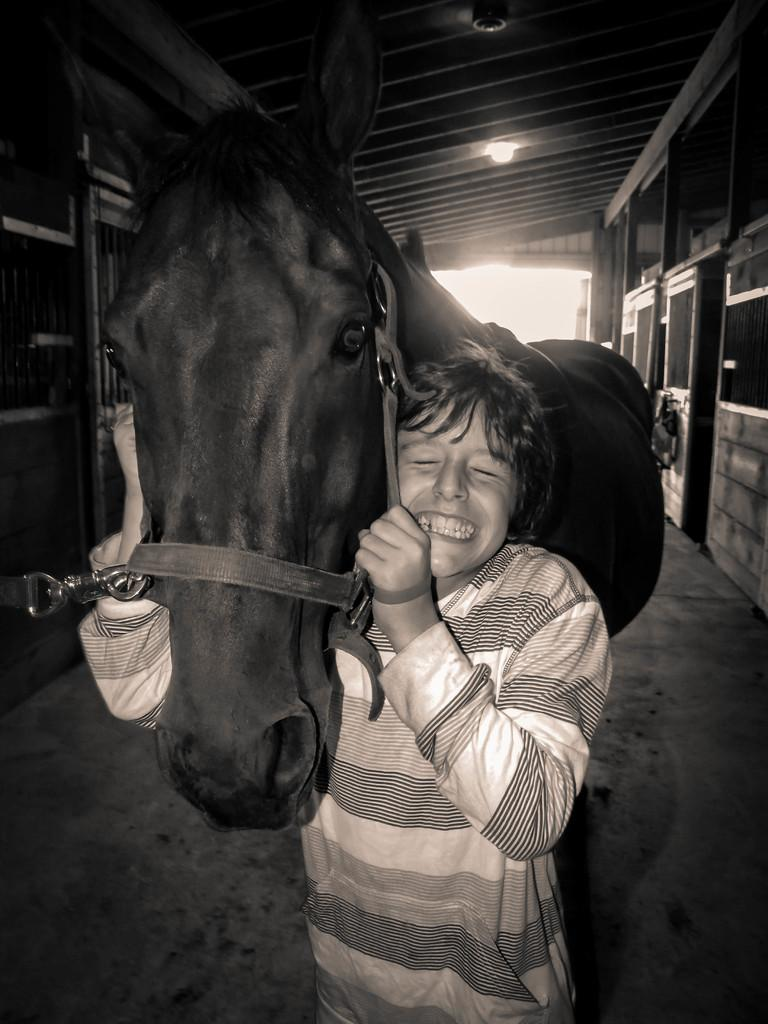Who is present in the image? There is a man in the image. What is the man doing with the horse? The man is holding a horse. What is the man's emotional state? The man is laughing. Where does the scene take place? The scene takes place in a room. What type of zebra can be seen in the image? There is no zebra present in the image; it features a man holding a horse. How many cubs are visible in the image? There are no cubs present in the image. 